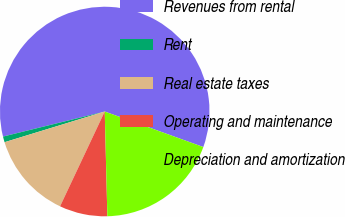Convert chart. <chart><loc_0><loc_0><loc_500><loc_500><pie_chart><fcel>Revenues from rental<fcel>Rent<fcel>Real estate taxes<fcel>Operating and maintenance<fcel>Depreciation and amortization<nl><fcel>59.35%<fcel>0.89%<fcel>13.26%<fcel>7.41%<fcel>19.1%<nl></chart> 